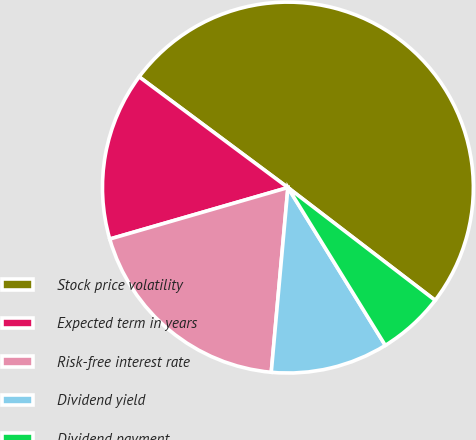Convert chart to OTSL. <chart><loc_0><loc_0><loc_500><loc_500><pie_chart><fcel>Stock price volatility<fcel>Expected term in years<fcel>Risk-free interest rate<fcel>Dividend yield<fcel>Dividend payment<nl><fcel>50.21%<fcel>14.66%<fcel>19.09%<fcel>10.23%<fcel>5.8%<nl></chart> 